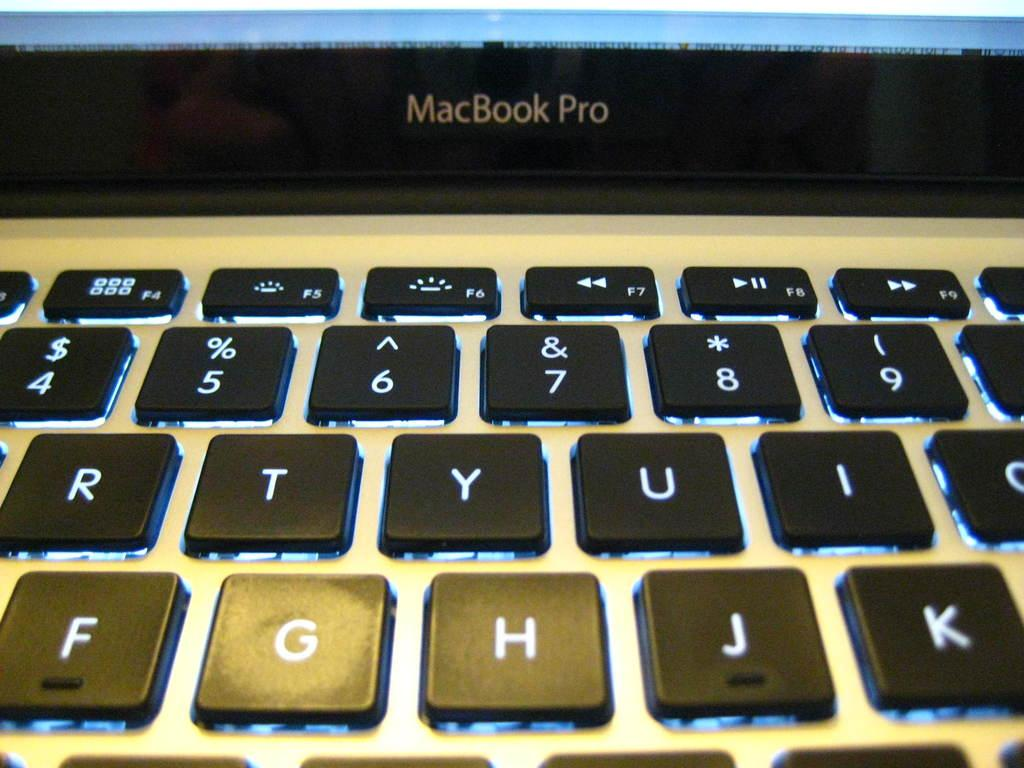What type of device is visible in the image? There is a MacBook Pro laptop in the image. What other electronic device is present in the image? There is a keyboard in the image. What type of meat is being cooked on the laptop in the image? There is no meat or cooking activity present in the image; it features a MacBook Pro laptop and a keyboard. What time is it according to the watch in the image? There is no watch present in the image. 